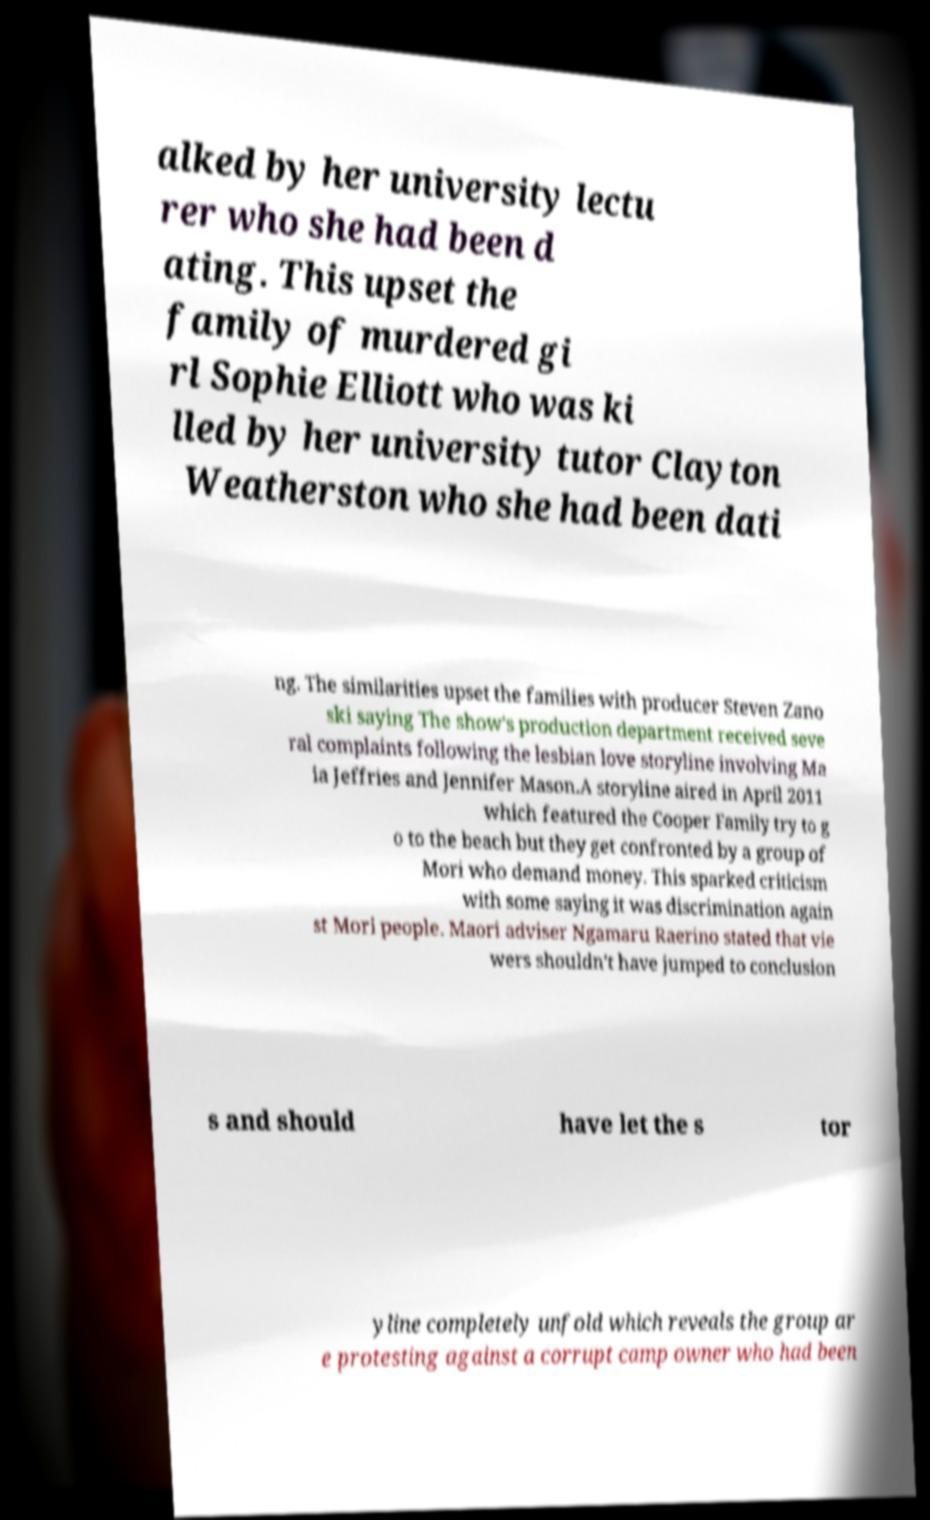For documentation purposes, I need the text within this image transcribed. Could you provide that? alked by her university lectu rer who she had been d ating. This upset the family of murdered gi rl Sophie Elliott who was ki lled by her university tutor Clayton Weatherston who she had been dati ng. The similarities upset the families with producer Steven Zano ski saying The show's production department received seve ral complaints following the lesbian love storyline involving Ma ia Jeffries and Jennifer Mason.A storyline aired in April 2011 which featured the Cooper Family try to g o to the beach but they get confronted by a group of Mori who demand money. This sparked criticism with some saying it was discrimination again st Mori people. Maori adviser Ngamaru Raerino stated that vie wers shouldn't have jumped to conclusion s and should have let the s tor yline completely unfold which reveals the group ar e protesting against a corrupt camp owner who had been 